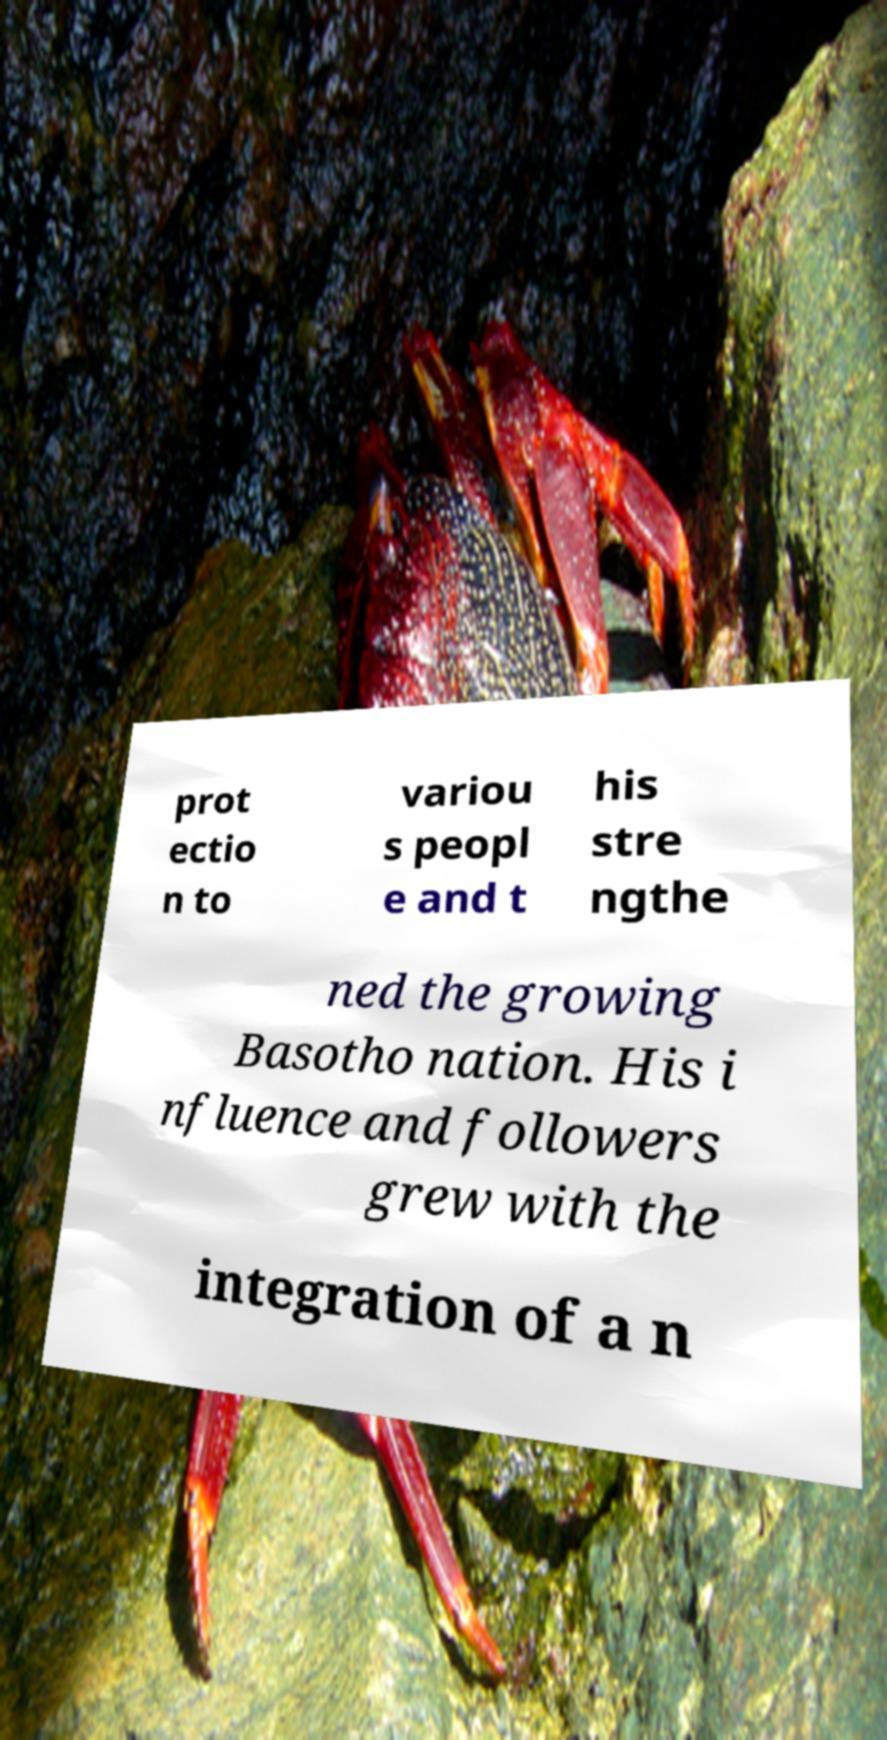What messages or text are displayed in this image? I need them in a readable, typed format. prot ectio n to variou s peopl e and t his stre ngthe ned the growing Basotho nation. His i nfluence and followers grew with the integration of a n 